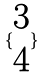<formula> <loc_0><loc_0><loc_500><loc_500>\{ \begin{matrix} 3 \\ 4 \end{matrix} \}</formula> 